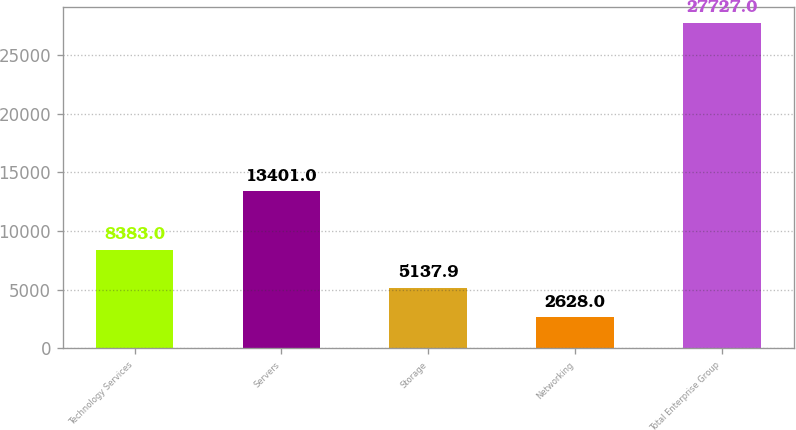Convert chart. <chart><loc_0><loc_0><loc_500><loc_500><bar_chart><fcel>Technology Services<fcel>Servers<fcel>Storage<fcel>Networking<fcel>Total Enterprise Group<nl><fcel>8383<fcel>13401<fcel>5137.9<fcel>2628<fcel>27727<nl></chart> 